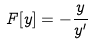Convert formula to latex. <formula><loc_0><loc_0><loc_500><loc_500>F [ y ] = - \frac { y } { y ^ { \prime } }</formula> 